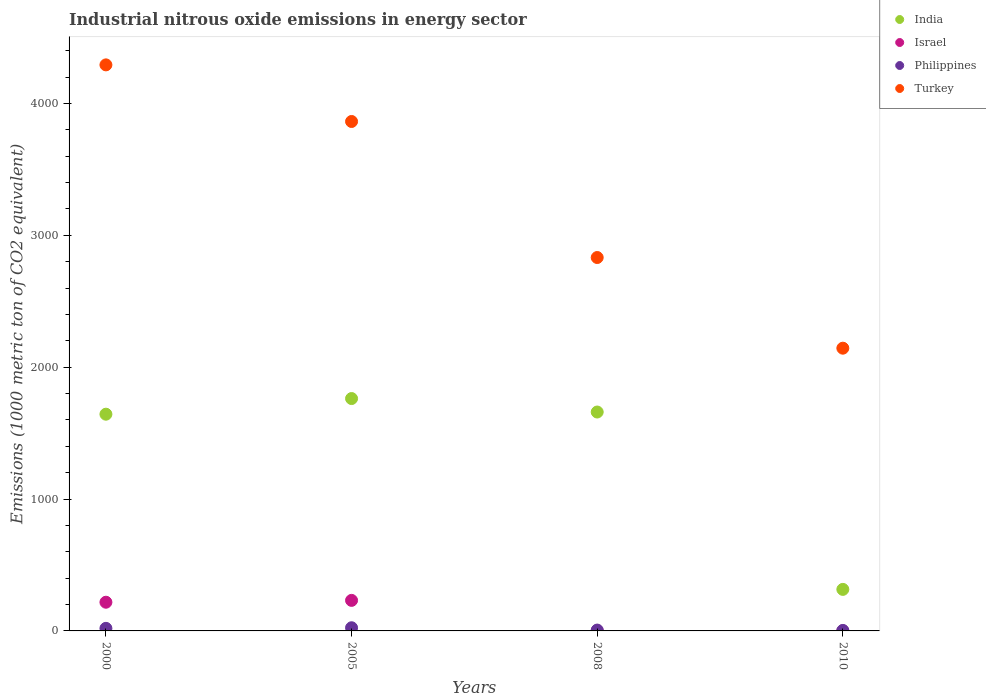What is the amount of industrial nitrous oxide emitted in India in 2010?
Provide a short and direct response. 314.9. Across all years, what is the maximum amount of industrial nitrous oxide emitted in Turkey?
Ensure brevity in your answer.  4292. Across all years, what is the minimum amount of industrial nitrous oxide emitted in India?
Provide a short and direct response. 314.9. In which year was the amount of industrial nitrous oxide emitted in India maximum?
Offer a terse response. 2005. What is the total amount of industrial nitrous oxide emitted in Turkey in the graph?
Keep it short and to the point. 1.31e+04. What is the difference between the amount of industrial nitrous oxide emitted in India in 2005 and that in 2008?
Ensure brevity in your answer.  102.1. What is the difference between the amount of industrial nitrous oxide emitted in Turkey in 2000 and the amount of industrial nitrous oxide emitted in Philippines in 2008?
Provide a short and direct response. 4285.6. What is the average amount of industrial nitrous oxide emitted in Philippines per year?
Provide a succinct answer. 13.38. In the year 2005, what is the difference between the amount of industrial nitrous oxide emitted in Turkey and amount of industrial nitrous oxide emitted in India?
Offer a terse response. 2100.8. What is the ratio of the amount of industrial nitrous oxide emitted in Turkey in 2000 to that in 2010?
Provide a short and direct response. 2. Is the amount of industrial nitrous oxide emitted in Philippines in 2008 less than that in 2010?
Offer a very short reply. No. Is the difference between the amount of industrial nitrous oxide emitted in Turkey in 2000 and 2008 greater than the difference between the amount of industrial nitrous oxide emitted in India in 2000 and 2008?
Your answer should be very brief. Yes. What is the difference between the highest and the second highest amount of industrial nitrous oxide emitted in Turkey?
Offer a terse response. 429.3. What is the difference between the highest and the lowest amount of industrial nitrous oxide emitted in Philippines?
Give a very brief answer. 20.4. In how many years, is the amount of industrial nitrous oxide emitted in Turkey greater than the average amount of industrial nitrous oxide emitted in Turkey taken over all years?
Ensure brevity in your answer.  2. Is the sum of the amount of industrial nitrous oxide emitted in Israel in 2000 and 2010 greater than the maximum amount of industrial nitrous oxide emitted in Turkey across all years?
Make the answer very short. No. Is it the case that in every year, the sum of the amount of industrial nitrous oxide emitted in Turkey and amount of industrial nitrous oxide emitted in Philippines  is greater than the amount of industrial nitrous oxide emitted in Israel?
Offer a very short reply. Yes. Is the amount of industrial nitrous oxide emitted in Philippines strictly less than the amount of industrial nitrous oxide emitted in Turkey over the years?
Offer a terse response. Yes. Are the values on the major ticks of Y-axis written in scientific E-notation?
Offer a very short reply. No. How are the legend labels stacked?
Provide a short and direct response. Vertical. What is the title of the graph?
Your answer should be compact. Industrial nitrous oxide emissions in energy sector. What is the label or title of the X-axis?
Your answer should be compact. Years. What is the label or title of the Y-axis?
Your answer should be very brief. Emissions (1000 metric ton of CO2 equivalent). What is the Emissions (1000 metric ton of CO2 equivalent) of India in 2000?
Your answer should be very brief. 1643.3. What is the Emissions (1000 metric ton of CO2 equivalent) of Israel in 2000?
Keep it short and to the point. 217.6. What is the Emissions (1000 metric ton of CO2 equivalent) in Turkey in 2000?
Give a very brief answer. 4292. What is the Emissions (1000 metric ton of CO2 equivalent) in India in 2005?
Make the answer very short. 1761.9. What is the Emissions (1000 metric ton of CO2 equivalent) in Israel in 2005?
Your answer should be very brief. 231.6. What is the Emissions (1000 metric ton of CO2 equivalent) in Philippines in 2005?
Your answer should be compact. 24. What is the Emissions (1000 metric ton of CO2 equivalent) in Turkey in 2005?
Ensure brevity in your answer.  3862.7. What is the Emissions (1000 metric ton of CO2 equivalent) in India in 2008?
Your response must be concise. 1659.8. What is the Emissions (1000 metric ton of CO2 equivalent) in Israel in 2008?
Provide a short and direct response. 1. What is the Emissions (1000 metric ton of CO2 equivalent) of Philippines in 2008?
Offer a terse response. 6.4. What is the Emissions (1000 metric ton of CO2 equivalent) of Turkey in 2008?
Keep it short and to the point. 2831.3. What is the Emissions (1000 metric ton of CO2 equivalent) of India in 2010?
Give a very brief answer. 314.9. What is the Emissions (1000 metric ton of CO2 equivalent) in Turkey in 2010?
Provide a short and direct response. 2143.8. Across all years, what is the maximum Emissions (1000 metric ton of CO2 equivalent) in India?
Offer a terse response. 1761.9. Across all years, what is the maximum Emissions (1000 metric ton of CO2 equivalent) of Israel?
Offer a very short reply. 231.6. Across all years, what is the maximum Emissions (1000 metric ton of CO2 equivalent) of Turkey?
Make the answer very short. 4292. Across all years, what is the minimum Emissions (1000 metric ton of CO2 equivalent) in India?
Your answer should be compact. 314.9. Across all years, what is the minimum Emissions (1000 metric ton of CO2 equivalent) of Turkey?
Your answer should be compact. 2143.8. What is the total Emissions (1000 metric ton of CO2 equivalent) in India in the graph?
Provide a short and direct response. 5379.9. What is the total Emissions (1000 metric ton of CO2 equivalent) in Israel in the graph?
Make the answer very short. 450.8. What is the total Emissions (1000 metric ton of CO2 equivalent) in Philippines in the graph?
Your response must be concise. 53.5. What is the total Emissions (1000 metric ton of CO2 equivalent) of Turkey in the graph?
Your response must be concise. 1.31e+04. What is the difference between the Emissions (1000 metric ton of CO2 equivalent) in India in 2000 and that in 2005?
Provide a short and direct response. -118.6. What is the difference between the Emissions (1000 metric ton of CO2 equivalent) of Israel in 2000 and that in 2005?
Keep it short and to the point. -14. What is the difference between the Emissions (1000 metric ton of CO2 equivalent) of Philippines in 2000 and that in 2005?
Ensure brevity in your answer.  -4.5. What is the difference between the Emissions (1000 metric ton of CO2 equivalent) in Turkey in 2000 and that in 2005?
Provide a short and direct response. 429.3. What is the difference between the Emissions (1000 metric ton of CO2 equivalent) in India in 2000 and that in 2008?
Your response must be concise. -16.5. What is the difference between the Emissions (1000 metric ton of CO2 equivalent) in Israel in 2000 and that in 2008?
Offer a very short reply. 216.6. What is the difference between the Emissions (1000 metric ton of CO2 equivalent) of Philippines in 2000 and that in 2008?
Your response must be concise. 13.1. What is the difference between the Emissions (1000 metric ton of CO2 equivalent) in Turkey in 2000 and that in 2008?
Make the answer very short. 1460.7. What is the difference between the Emissions (1000 metric ton of CO2 equivalent) of India in 2000 and that in 2010?
Give a very brief answer. 1328.4. What is the difference between the Emissions (1000 metric ton of CO2 equivalent) in Israel in 2000 and that in 2010?
Ensure brevity in your answer.  217. What is the difference between the Emissions (1000 metric ton of CO2 equivalent) of Philippines in 2000 and that in 2010?
Give a very brief answer. 15.9. What is the difference between the Emissions (1000 metric ton of CO2 equivalent) in Turkey in 2000 and that in 2010?
Make the answer very short. 2148.2. What is the difference between the Emissions (1000 metric ton of CO2 equivalent) in India in 2005 and that in 2008?
Keep it short and to the point. 102.1. What is the difference between the Emissions (1000 metric ton of CO2 equivalent) of Israel in 2005 and that in 2008?
Make the answer very short. 230.6. What is the difference between the Emissions (1000 metric ton of CO2 equivalent) of Turkey in 2005 and that in 2008?
Offer a terse response. 1031.4. What is the difference between the Emissions (1000 metric ton of CO2 equivalent) of India in 2005 and that in 2010?
Provide a succinct answer. 1447. What is the difference between the Emissions (1000 metric ton of CO2 equivalent) of Israel in 2005 and that in 2010?
Offer a terse response. 231. What is the difference between the Emissions (1000 metric ton of CO2 equivalent) in Philippines in 2005 and that in 2010?
Provide a short and direct response. 20.4. What is the difference between the Emissions (1000 metric ton of CO2 equivalent) in Turkey in 2005 and that in 2010?
Your answer should be very brief. 1718.9. What is the difference between the Emissions (1000 metric ton of CO2 equivalent) of India in 2008 and that in 2010?
Your response must be concise. 1344.9. What is the difference between the Emissions (1000 metric ton of CO2 equivalent) in Philippines in 2008 and that in 2010?
Your response must be concise. 2.8. What is the difference between the Emissions (1000 metric ton of CO2 equivalent) of Turkey in 2008 and that in 2010?
Offer a terse response. 687.5. What is the difference between the Emissions (1000 metric ton of CO2 equivalent) in India in 2000 and the Emissions (1000 metric ton of CO2 equivalent) in Israel in 2005?
Provide a succinct answer. 1411.7. What is the difference between the Emissions (1000 metric ton of CO2 equivalent) in India in 2000 and the Emissions (1000 metric ton of CO2 equivalent) in Philippines in 2005?
Your response must be concise. 1619.3. What is the difference between the Emissions (1000 metric ton of CO2 equivalent) in India in 2000 and the Emissions (1000 metric ton of CO2 equivalent) in Turkey in 2005?
Your response must be concise. -2219.4. What is the difference between the Emissions (1000 metric ton of CO2 equivalent) in Israel in 2000 and the Emissions (1000 metric ton of CO2 equivalent) in Philippines in 2005?
Your answer should be compact. 193.6. What is the difference between the Emissions (1000 metric ton of CO2 equivalent) in Israel in 2000 and the Emissions (1000 metric ton of CO2 equivalent) in Turkey in 2005?
Give a very brief answer. -3645.1. What is the difference between the Emissions (1000 metric ton of CO2 equivalent) of Philippines in 2000 and the Emissions (1000 metric ton of CO2 equivalent) of Turkey in 2005?
Make the answer very short. -3843.2. What is the difference between the Emissions (1000 metric ton of CO2 equivalent) of India in 2000 and the Emissions (1000 metric ton of CO2 equivalent) of Israel in 2008?
Keep it short and to the point. 1642.3. What is the difference between the Emissions (1000 metric ton of CO2 equivalent) of India in 2000 and the Emissions (1000 metric ton of CO2 equivalent) of Philippines in 2008?
Make the answer very short. 1636.9. What is the difference between the Emissions (1000 metric ton of CO2 equivalent) in India in 2000 and the Emissions (1000 metric ton of CO2 equivalent) in Turkey in 2008?
Provide a succinct answer. -1188. What is the difference between the Emissions (1000 metric ton of CO2 equivalent) of Israel in 2000 and the Emissions (1000 metric ton of CO2 equivalent) of Philippines in 2008?
Provide a succinct answer. 211.2. What is the difference between the Emissions (1000 metric ton of CO2 equivalent) in Israel in 2000 and the Emissions (1000 metric ton of CO2 equivalent) in Turkey in 2008?
Offer a very short reply. -2613.7. What is the difference between the Emissions (1000 metric ton of CO2 equivalent) of Philippines in 2000 and the Emissions (1000 metric ton of CO2 equivalent) of Turkey in 2008?
Provide a short and direct response. -2811.8. What is the difference between the Emissions (1000 metric ton of CO2 equivalent) of India in 2000 and the Emissions (1000 metric ton of CO2 equivalent) of Israel in 2010?
Provide a short and direct response. 1642.7. What is the difference between the Emissions (1000 metric ton of CO2 equivalent) in India in 2000 and the Emissions (1000 metric ton of CO2 equivalent) in Philippines in 2010?
Ensure brevity in your answer.  1639.7. What is the difference between the Emissions (1000 metric ton of CO2 equivalent) in India in 2000 and the Emissions (1000 metric ton of CO2 equivalent) in Turkey in 2010?
Your answer should be very brief. -500.5. What is the difference between the Emissions (1000 metric ton of CO2 equivalent) in Israel in 2000 and the Emissions (1000 metric ton of CO2 equivalent) in Philippines in 2010?
Your answer should be compact. 214. What is the difference between the Emissions (1000 metric ton of CO2 equivalent) of Israel in 2000 and the Emissions (1000 metric ton of CO2 equivalent) of Turkey in 2010?
Ensure brevity in your answer.  -1926.2. What is the difference between the Emissions (1000 metric ton of CO2 equivalent) in Philippines in 2000 and the Emissions (1000 metric ton of CO2 equivalent) in Turkey in 2010?
Make the answer very short. -2124.3. What is the difference between the Emissions (1000 metric ton of CO2 equivalent) of India in 2005 and the Emissions (1000 metric ton of CO2 equivalent) of Israel in 2008?
Your answer should be very brief. 1760.9. What is the difference between the Emissions (1000 metric ton of CO2 equivalent) of India in 2005 and the Emissions (1000 metric ton of CO2 equivalent) of Philippines in 2008?
Keep it short and to the point. 1755.5. What is the difference between the Emissions (1000 metric ton of CO2 equivalent) in India in 2005 and the Emissions (1000 metric ton of CO2 equivalent) in Turkey in 2008?
Make the answer very short. -1069.4. What is the difference between the Emissions (1000 metric ton of CO2 equivalent) of Israel in 2005 and the Emissions (1000 metric ton of CO2 equivalent) of Philippines in 2008?
Offer a very short reply. 225.2. What is the difference between the Emissions (1000 metric ton of CO2 equivalent) of Israel in 2005 and the Emissions (1000 metric ton of CO2 equivalent) of Turkey in 2008?
Provide a succinct answer. -2599.7. What is the difference between the Emissions (1000 metric ton of CO2 equivalent) of Philippines in 2005 and the Emissions (1000 metric ton of CO2 equivalent) of Turkey in 2008?
Keep it short and to the point. -2807.3. What is the difference between the Emissions (1000 metric ton of CO2 equivalent) of India in 2005 and the Emissions (1000 metric ton of CO2 equivalent) of Israel in 2010?
Your response must be concise. 1761.3. What is the difference between the Emissions (1000 metric ton of CO2 equivalent) of India in 2005 and the Emissions (1000 metric ton of CO2 equivalent) of Philippines in 2010?
Your response must be concise. 1758.3. What is the difference between the Emissions (1000 metric ton of CO2 equivalent) in India in 2005 and the Emissions (1000 metric ton of CO2 equivalent) in Turkey in 2010?
Your answer should be very brief. -381.9. What is the difference between the Emissions (1000 metric ton of CO2 equivalent) in Israel in 2005 and the Emissions (1000 metric ton of CO2 equivalent) in Philippines in 2010?
Offer a very short reply. 228. What is the difference between the Emissions (1000 metric ton of CO2 equivalent) in Israel in 2005 and the Emissions (1000 metric ton of CO2 equivalent) in Turkey in 2010?
Offer a terse response. -1912.2. What is the difference between the Emissions (1000 metric ton of CO2 equivalent) in Philippines in 2005 and the Emissions (1000 metric ton of CO2 equivalent) in Turkey in 2010?
Your answer should be compact. -2119.8. What is the difference between the Emissions (1000 metric ton of CO2 equivalent) of India in 2008 and the Emissions (1000 metric ton of CO2 equivalent) of Israel in 2010?
Your response must be concise. 1659.2. What is the difference between the Emissions (1000 metric ton of CO2 equivalent) of India in 2008 and the Emissions (1000 metric ton of CO2 equivalent) of Philippines in 2010?
Offer a terse response. 1656.2. What is the difference between the Emissions (1000 metric ton of CO2 equivalent) in India in 2008 and the Emissions (1000 metric ton of CO2 equivalent) in Turkey in 2010?
Your response must be concise. -484. What is the difference between the Emissions (1000 metric ton of CO2 equivalent) in Israel in 2008 and the Emissions (1000 metric ton of CO2 equivalent) in Philippines in 2010?
Provide a succinct answer. -2.6. What is the difference between the Emissions (1000 metric ton of CO2 equivalent) of Israel in 2008 and the Emissions (1000 metric ton of CO2 equivalent) of Turkey in 2010?
Provide a short and direct response. -2142.8. What is the difference between the Emissions (1000 metric ton of CO2 equivalent) in Philippines in 2008 and the Emissions (1000 metric ton of CO2 equivalent) in Turkey in 2010?
Offer a terse response. -2137.4. What is the average Emissions (1000 metric ton of CO2 equivalent) of India per year?
Make the answer very short. 1344.97. What is the average Emissions (1000 metric ton of CO2 equivalent) of Israel per year?
Ensure brevity in your answer.  112.7. What is the average Emissions (1000 metric ton of CO2 equivalent) in Philippines per year?
Offer a very short reply. 13.38. What is the average Emissions (1000 metric ton of CO2 equivalent) in Turkey per year?
Give a very brief answer. 3282.45. In the year 2000, what is the difference between the Emissions (1000 metric ton of CO2 equivalent) of India and Emissions (1000 metric ton of CO2 equivalent) of Israel?
Make the answer very short. 1425.7. In the year 2000, what is the difference between the Emissions (1000 metric ton of CO2 equivalent) in India and Emissions (1000 metric ton of CO2 equivalent) in Philippines?
Ensure brevity in your answer.  1623.8. In the year 2000, what is the difference between the Emissions (1000 metric ton of CO2 equivalent) of India and Emissions (1000 metric ton of CO2 equivalent) of Turkey?
Provide a short and direct response. -2648.7. In the year 2000, what is the difference between the Emissions (1000 metric ton of CO2 equivalent) of Israel and Emissions (1000 metric ton of CO2 equivalent) of Philippines?
Offer a terse response. 198.1. In the year 2000, what is the difference between the Emissions (1000 metric ton of CO2 equivalent) of Israel and Emissions (1000 metric ton of CO2 equivalent) of Turkey?
Give a very brief answer. -4074.4. In the year 2000, what is the difference between the Emissions (1000 metric ton of CO2 equivalent) in Philippines and Emissions (1000 metric ton of CO2 equivalent) in Turkey?
Provide a short and direct response. -4272.5. In the year 2005, what is the difference between the Emissions (1000 metric ton of CO2 equivalent) of India and Emissions (1000 metric ton of CO2 equivalent) of Israel?
Ensure brevity in your answer.  1530.3. In the year 2005, what is the difference between the Emissions (1000 metric ton of CO2 equivalent) in India and Emissions (1000 metric ton of CO2 equivalent) in Philippines?
Your answer should be very brief. 1737.9. In the year 2005, what is the difference between the Emissions (1000 metric ton of CO2 equivalent) of India and Emissions (1000 metric ton of CO2 equivalent) of Turkey?
Your answer should be very brief. -2100.8. In the year 2005, what is the difference between the Emissions (1000 metric ton of CO2 equivalent) of Israel and Emissions (1000 metric ton of CO2 equivalent) of Philippines?
Provide a short and direct response. 207.6. In the year 2005, what is the difference between the Emissions (1000 metric ton of CO2 equivalent) of Israel and Emissions (1000 metric ton of CO2 equivalent) of Turkey?
Ensure brevity in your answer.  -3631.1. In the year 2005, what is the difference between the Emissions (1000 metric ton of CO2 equivalent) of Philippines and Emissions (1000 metric ton of CO2 equivalent) of Turkey?
Offer a terse response. -3838.7. In the year 2008, what is the difference between the Emissions (1000 metric ton of CO2 equivalent) in India and Emissions (1000 metric ton of CO2 equivalent) in Israel?
Your response must be concise. 1658.8. In the year 2008, what is the difference between the Emissions (1000 metric ton of CO2 equivalent) of India and Emissions (1000 metric ton of CO2 equivalent) of Philippines?
Give a very brief answer. 1653.4. In the year 2008, what is the difference between the Emissions (1000 metric ton of CO2 equivalent) in India and Emissions (1000 metric ton of CO2 equivalent) in Turkey?
Offer a very short reply. -1171.5. In the year 2008, what is the difference between the Emissions (1000 metric ton of CO2 equivalent) of Israel and Emissions (1000 metric ton of CO2 equivalent) of Turkey?
Provide a succinct answer. -2830.3. In the year 2008, what is the difference between the Emissions (1000 metric ton of CO2 equivalent) in Philippines and Emissions (1000 metric ton of CO2 equivalent) in Turkey?
Provide a short and direct response. -2824.9. In the year 2010, what is the difference between the Emissions (1000 metric ton of CO2 equivalent) of India and Emissions (1000 metric ton of CO2 equivalent) of Israel?
Your answer should be very brief. 314.3. In the year 2010, what is the difference between the Emissions (1000 metric ton of CO2 equivalent) in India and Emissions (1000 metric ton of CO2 equivalent) in Philippines?
Ensure brevity in your answer.  311.3. In the year 2010, what is the difference between the Emissions (1000 metric ton of CO2 equivalent) of India and Emissions (1000 metric ton of CO2 equivalent) of Turkey?
Your response must be concise. -1828.9. In the year 2010, what is the difference between the Emissions (1000 metric ton of CO2 equivalent) of Israel and Emissions (1000 metric ton of CO2 equivalent) of Turkey?
Ensure brevity in your answer.  -2143.2. In the year 2010, what is the difference between the Emissions (1000 metric ton of CO2 equivalent) in Philippines and Emissions (1000 metric ton of CO2 equivalent) in Turkey?
Give a very brief answer. -2140.2. What is the ratio of the Emissions (1000 metric ton of CO2 equivalent) of India in 2000 to that in 2005?
Your answer should be compact. 0.93. What is the ratio of the Emissions (1000 metric ton of CO2 equivalent) in Israel in 2000 to that in 2005?
Your answer should be compact. 0.94. What is the ratio of the Emissions (1000 metric ton of CO2 equivalent) of Philippines in 2000 to that in 2005?
Offer a very short reply. 0.81. What is the ratio of the Emissions (1000 metric ton of CO2 equivalent) in India in 2000 to that in 2008?
Provide a succinct answer. 0.99. What is the ratio of the Emissions (1000 metric ton of CO2 equivalent) in Israel in 2000 to that in 2008?
Give a very brief answer. 217.6. What is the ratio of the Emissions (1000 metric ton of CO2 equivalent) in Philippines in 2000 to that in 2008?
Your answer should be compact. 3.05. What is the ratio of the Emissions (1000 metric ton of CO2 equivalent) in Turkey in 2000 to that in 2008?
Your answer should be very brief. 1.52. What is the ratio of the Emissions (1000 metric ton of CO2 equivalent) of India in 2000 to that in 2010?
Provide a short and direct response. 5.22. What is the ratio of the Emissions (1000 metric ton of CO2 equivalent) of Israel in 2000 to that in 2010?
Your answer should be very brief. 362.67. What is the ratio of the Emissions (1000 metric ton of CO2 equivalent) of Philippines in 2000 to that in 2010?
Offer a terse response. 5.42. What is the ratio of the Emissions (1000 metric ton of CO2 equivalent) of Turkey in 2000 to that in 2010?
Provide a short and direct response. 2. What is the ratio of the Emissions (1000 metric ton of CO2 equivalent) of India in 2005 to that in 2008?
Offer a terse response. 1.06. What is the ratio of the Emissions (1000 metric ton of CO2 equivalent) of Israel in 2005 to that in 2008?
Ensure brevity in your answer.  231.6. What is the ratio of the Emissions (1000 metric ton of CO2 equivalent) in Philippines in 2005 to that in 2008?
Ensure brevity in your answer.  3.75. What is the ratio of the Emissions (1000 metric ton of CO2 equivalent) in Turkey in 2005 to that in 2008?
Provide a succinct answer. 1.36. What is the ratio of the Emissions (1000 metric ton of CO2 equivalent) in India in 2005 to that in 2010?
Offer a terse response. 5.6. What is the ratio of the Emissions (1000 metric ton of CO2 equivalent) in Israel in 2005 to that in 2010?
Provide a succinct answer. 386. What is the ratio of the Emissions (1000 metric ton of CO2 equivalent) in Turkey in 2005 to that in 2010?
Make the answer very short. 1.8. What is the ratio of the Emissions (1000 metric ton of CO2 equivalent) of India in 2008 to that in 2010?
Your answer should be compact. 5.27. What is the ratio of the Emissions (1000 metric ton of CO2 equivalent) in Israel in 2008 to that in 2010?
Make the answer very short. 1.67. What is the ratio of the Emissions (1000 metric ton of CO2 equivalent) of Philippines in 2008 to that in 2010?
Give a very brief answer. 1.78. What is the ratio of the Emissions (1000 metric ton of CO2 equivalent) in Turkey in 2008 to that in 2010?
Ensure brevity in your answer.  1.32. What is the difference between the highest and the second highest Emissions (1000 metric ton of CO2 equivalent) of India?
Make the answer very short. 102.1. What is the difference between the highest and the second highest Emissions (1000 metric ton of CO2 equivalent) of Turkey?
Offer a very short reply. 429.3. What is the difference between the highest and the lowest Emissions (1000 metric ton of CO2 equivalent) in India?
Give a very brief answer. 1447. What is the difference between the highest and the lowest Emissions (1000 metric ton of CO2 equivalent) in Israel?
Your answer should be compact. 231. What is the difference between the highest and the lowest Emissions (1000 metric ton of CO2 equivalent) of Philippines?
Offer a very short reply. 20.4. What is the difference between the highest and the lowest Emissions (1000 metric ton of CO2 equivalent) in Turkey?
Provide a short and direct response. 2148.2. 